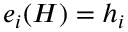<formula> <loc_0><loc_0><loc_500><loc_500>e _ { i } ( H ) = h _ { i }</formula> 